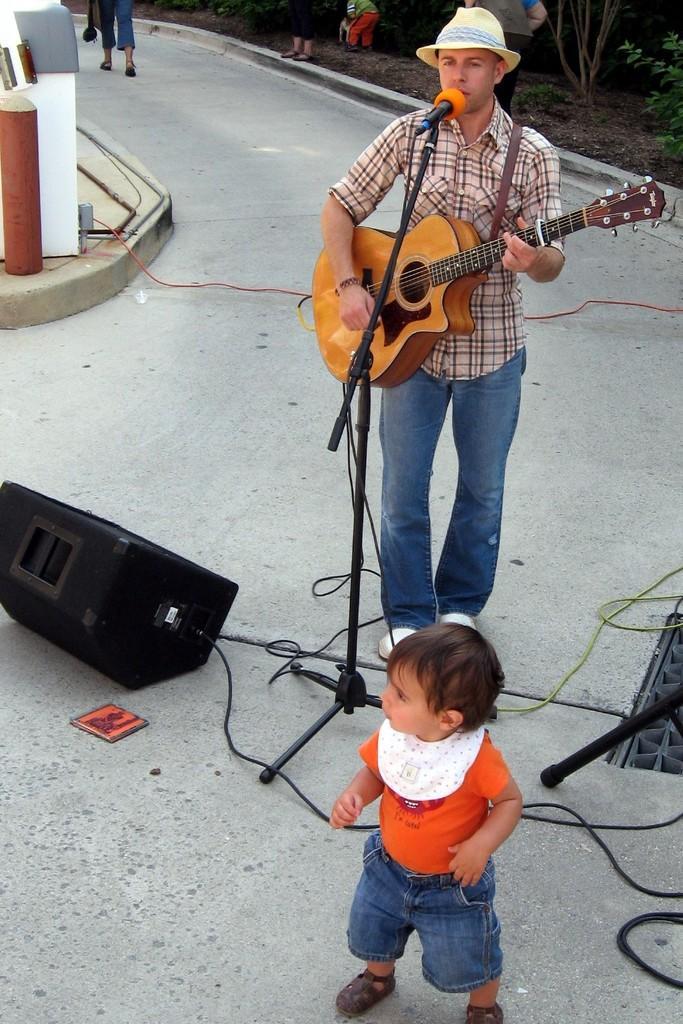In one or two sentences, can you explain what this image depicts? In the image we can see there is a man who is holding guitar in his hand and there is a little kid who is standing on the ground over here there is a speaker. 